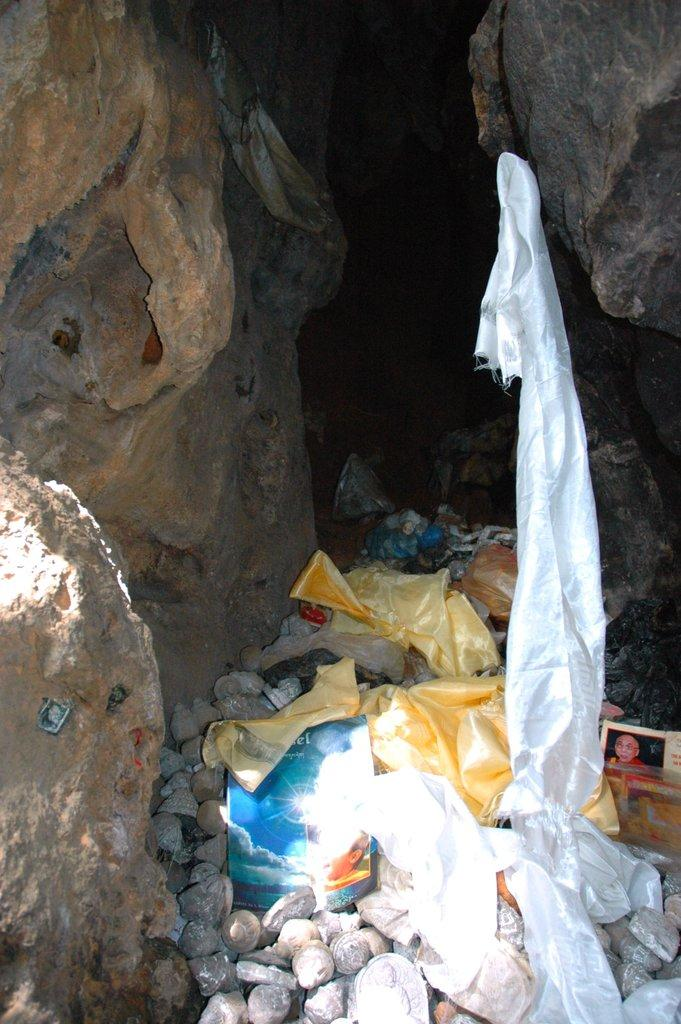What type of natural elements can be seen on both sides of the image? There are rocks on both the right and left sides of the image. What is located in the center of the image? There are pebbles, clothes, and books in the center of the image. Where is the kitty playing with a letter in the image? There is no kitty or letter present in the image. What type of trousers are being worn by the person in the image? There is no person visible in the image, so it is not possible to determine what type of trousers they might be wearing. 